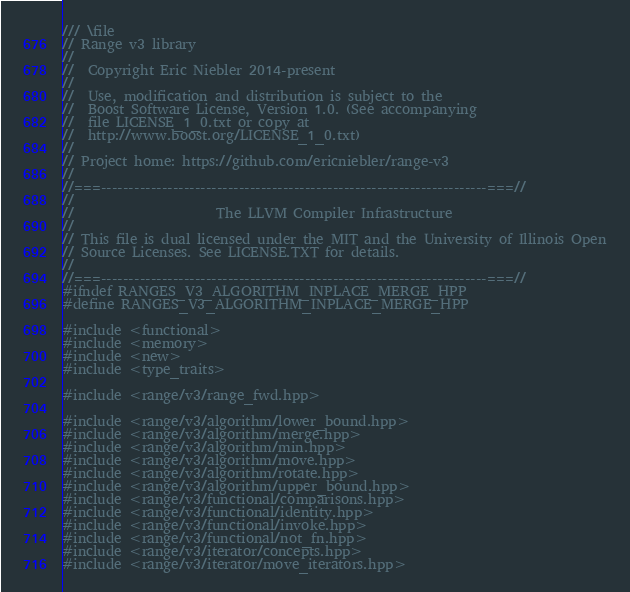<code> <loc_0><loc_0><loc_500><loc_500><_C++_>/// \file
// Range v3 library
//
//  Copyright Eric Niebler 2014-present
//
//  Use, modification and distribution is subject to the
//  Boost Software License, Version 1.0. (See accompanying
//  file LICENSE_1_0.txt or copy at
//  http://www.boost.org/LICENSE_1_0.txt)
//
// Project home: https://github.com/ericniebler/range-v3
//
//===----------------------------------------------------------------------===//
//
//                     The LLVM Compiler Infrastructure
//
// This file is dual licensed under the MIT and the University of Illinois Open
// Source Licenses. See LICENSE.TXT for details.
//
//===----------------------------------------------------------------------===//
#ifndef RANGES_V3_ALGORITHM_INPLACE_MERGE_HPP
#define RANGES_V3_ALGORITHM_INPLACE_MERGE_HPP

#include <functional>
#include <memory>
#include <new>
#include <type_traits>

#include <range/v3/range_fwd.hpp>

#include <range/v3/algorithm/lower_bound.hpp>
#include <range/v3/algorithm/merge.hpp>
#include <range/v3/algorithm/min.hpp>
#include <range/v3/algorithm/move.hpp>
#include <range/v3/algorithm/rotate.hpp>
#include <range/v3/algorithm/upper_bound.hpp>
#include <range/v3/functional/comparisons.hpp>
#include <range/v3/functional/identity.hpp>
#include <range/v3/functional/invoke.hpp>
#include <range/v3/functional/not_fn.hpp>
#include <range/v3/iterator/concepts.hpp>
#include <range/v3/iterator/move_iterators.hpp></code> 